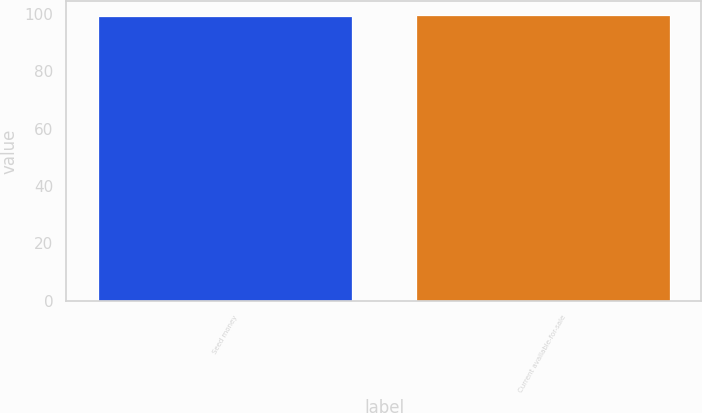Convert chart. <chart><loc_0><loc_0><loc_500><loc_500><bar_chart><fcel>Seed money<fcel>Current available-for-sale<nl><fcel>99.5<fcel>99.6<nl></chart> 